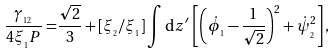Convert formula to latex. <formula><loc_0><loc_0><loc_500><loc_500>\frac { \gamma _ { _ { 1 2 } } } { 4 \xi _ { _ { 1 } } P } = & \frac { \sqrt { 2 } } { 3 } + [ \xi _ { _ { 2 } } / \xi _ { _ { 1 } } ] \int \text {d} z ^ { \prime } \, \left [ \left ( \dot { \phi } _ { _ { 1 } } - \frac { 1 } { \sqrt { 2 } } \right ) ^ { 2 } + \dot { \psi } _ { _ { 2 } } ^ { 2 } \right ] ,</formula> 